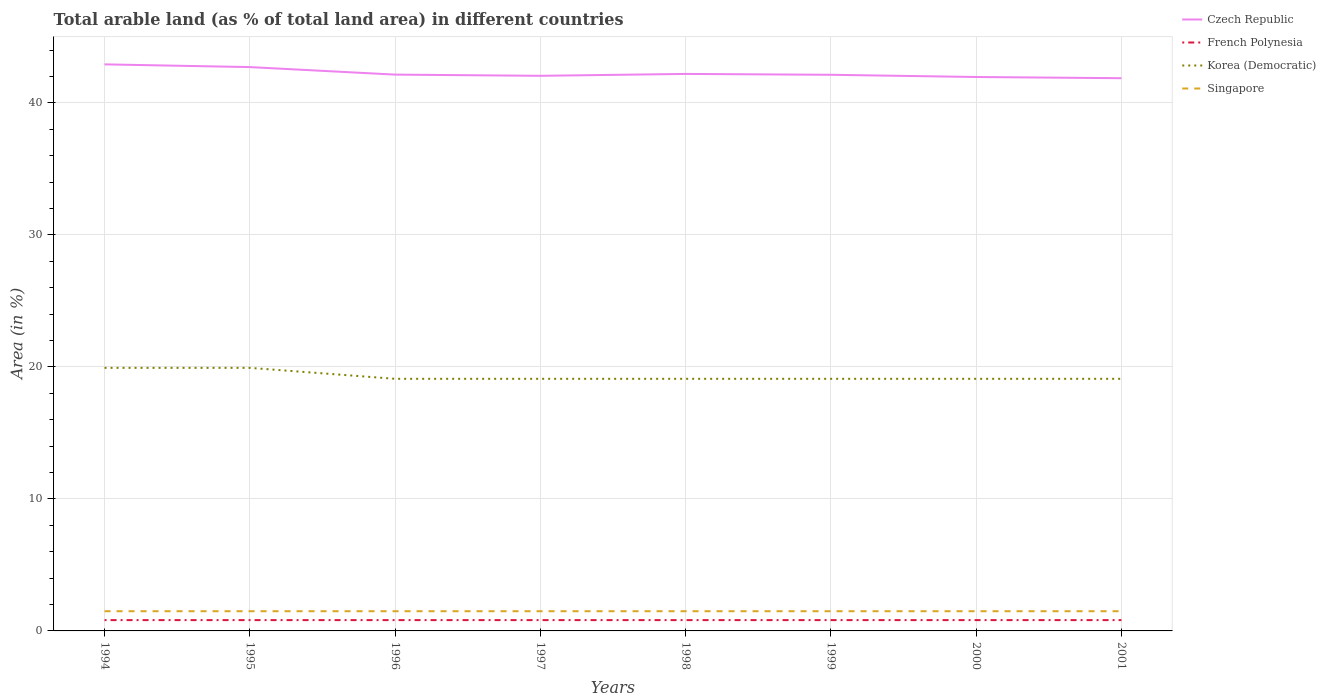How many different coloured lines are there?
Provide a succinct answer. 4. Is the number of lines equal to the number of legend labels?
Ensure brevity in your answer.  Yes. Across all years, what is the maximum percentage of arable land in Singapore?
Ensure brevity in your answer.  1.49. In which year was the percentage of arable land in French Polynesia maximum?
Your answer should be compact. 1994. What is the total percentage of arable land in Czech Republic in the graph?
Provide a short and direct response. 0.23. What is the difference between the highest and the second highest percentage of arable land in Czech Republic?
Keep it short and to the point. 1.05. Is the percentage of arable land in Czech Republic strictly greater than the percentage of arable land in Korea (Democratic) over the years?
Give a very brief answer. No. How many lines are there?
Make the answer very short. 4. How many years are there in the graph?
Your response must be concise. 8. What is the difference between two consecutive major ticks on the Y-axis?
Ensure brevity in your answer.  10. Are the values on the major ticks of Y-axis written in scientific E-notation?
Your answer should be very brief. No. Where does the legend appear in the graph?
Give a very brief answer. Top right. How many legend labels are there?
Offer a very short reply. 4. What is the title of the graph?
Offer a very short reply. Total arable land (as % of total land area) in different countries. Does "Zimbabwe" appear as one of the legend labels in the graph?
Your response must be concise. No. What is the label or title of the X-axis?
Keep it short and to the point. Years. What is the label or title of the Y-axis?
Your answer should be very brief. Area (in %). What is the Area (in %) of Czech Republic in 1994?
Offer a terse response. 42.93. What is the Area (in %) in French Polynesia in 1994?
Offer a terse response. 0.82. What is the Area (in %) of Korea (Democratic) in 1994?
Ensure brevity in your answer.  19.93. What is the Area (in %) in Singapore in 1994?
Keep it short and to the point. 1.49. What is the Area (in %) of Czech Republic in 1995?
Your answer should be very brief. 42.72. What is the Area (in %) of French Polynesia in 1995?
Give a very brief answer. 0.82. What is the Area (in %) of Korea (Democratic) in 1995?
Offer a terse response. 19.93. What is the Area (in %) in Singapore in 1995?
Your response must be concise. 1.49. What is the Area (in %) in Czech Republic in 1996?
Make the answer very short. 42.15. What is the Area (in %) of French Polynesia in 1996?
Offer a terse response. 0.82. What is the Area (in %) in Korea (Democratic) in 1996?
Offer a very short reply. 19.1. What is the Area (in %) in Singapore in 1996?
Keep it short and to the point. 1.49. What is the Area (in %) in Czech Republic in 1997?
Offer a terse response. 42.06. What is the Area (in %) in French Polynesia in 1997?
Provide a short and direct response. 0.82. What is the Area (in %) of Korea (Democratic) in 1997?
Your answer should be compact. 19.1. What is the Area (in %) in Singapore in 1997?
Provide a short and direct response. 1.49. What is the Area (in %) of Czech Republic in 1998?
Offer a very short reply. 42.2. What is the Area (in %) in French Polynesia in 1998?
Your answer should be very brief. 0.82. What is the Area (in %) in Korea (Democratic) in 1998?
Offer a terse response. 19.1. What is the Area (in %) in Singapore in 1998?
Ensure brevity in your answer.  1.49. What is the Area (in %) in Czech Republic in 1999?
Ensure brevity in your answer.  42.14. What is the Area (in %) in French Polynesia in 1999?
Your answer should be very brief. 0.82. What is the Area (in %) of Korea (Democratic) in 1999?
Ensure brevity in your answer.  19.1. What is the Area (in %) in Singapore in 1999?
Ensure brevity in your answer.  1.49. What is the Area (in %) of Czech Republic in 2000?
Offer a very short reply. 41.97. What is the Area (in %) in French Polynesia in 2000?
Your answer should be very brief. 0.82. What is the Area (in %) of Korea (Democratic) in 2000?
Your answer should be compact. 19.1. What is the Area (in %) of Singapore in 2000?
Offer a very short reply. 1.49. What is the Area (in %) in Czech Republic in 2001?
Offer a terse response. 41.88. What is the Area (in %) in French Polynesia in 2001?
Your answer should be very brief. 0.82. What is the Area (in %) in Korea (Democratic) in 2001?
Your answer should be compact. 19.1. What is the Area (in %) of Singapore in 2001?
Your answer should be very brief. 1.49. Across all years, what is the maximum Area (in %) in Czech Republic?
Give a very brief answer. 42.93. Across all years, what is the maximum Area (in %) in French Polynesia?
Make the answer very short. 0.82. Across all years, what is the maximum Area (in %) in Korea (Democratic)?
Make the answer very short. 19.93. Across all years, what is the maximum Area (in %) of Singapore?
Keep it short and to the point. 1.49. Across all years, what is the minimum Area (in %) in Czech Republic?
Make the answer very short. 41.88. Across all years, what is the minimum Area (in %) of French Polynesia?
Ensure brevity in your answer.  0.82. Across all years, what is the minimum Area (in %) of Korea (Democratic)?
Ensure brevity in your answer.  19.1. Across all years, what is the minimum Area (in %) in Singapore?
Your response must be concise. 1.49. What is the total Area (in %) of Czech Republic in the graph?
Provide a short and direct response. 338.05. What is the total Area (in %) of French Polynesia in the graph?
Give a very brief answer. 6.56. What is the total Area (in %) of Korea (Democratic) in the graph?
Your response must be concise. 154.47. What is the total Area (in %) in Singapore in the graph?
Your answer should be very brief. 11.94. What is the difference between the Area (in %) of Czech Republic in 1994 and that in 1995?
Offer a terse response. 0.21. What is the difference between the Area (in %) of French Polynesia in 1994 and that in 1995?
Ensure brevity in your answer.  0. What is the difference between the Area (in %) of Korea (Democratic) in 1994 and that in 1995?
Provide a short and direct response. 0. What is the difference between the Area (in %) of Czech Republic in 1994 and that in 1996?
Offer a terse response. 0.78. What is the difference between the Area (in %) of French Polynesia in 1994 and that in 1996?
Your answer should be very brief. 0. What is the difference between the Area (in %) in Korea (Democratic) in 1994 and that in 1996?
Give a very brief answer. 0.83. What is the difference between the Area (in %) of Czech Republic in 1994 and that in 1997?
Provide a short and direct response. 0.87. What is the difference between the Area (in %) of Korea (Democratic) in 1994 and that in 1997?
Offer a terse response. 0.83. What is the difference between the Area (in %) of Singapore in 1994 and that in 1997?
Give a very brief answer. 0. What is the difference between the Area (in %) of Czech Republic in 1994 and that in 1998?
Your answer should be compact. 0.72. What is the difference between the Area (in %) in Korea (Democratic) in 1994 and that in 1998?
Your answer should be very brief. 0.83. What is the difference between the Area (in %) in Singapore in 1994 and that in 1998?
Provide a succinct answer. 0. What is the difference between the Area (in %) in Czech Republic in 1994 and that in 1999?
Provide a short and direct response. 0.79. What is the difference between the Area (in %) of French Polynesia in 1994 and that in 1999?
Offer a very short reply. 0. What is the difference between the Area (in %) of Korea (Democratic) in 1994 and that in 1999?
Provide a short and direct response. 0.83. What is the difference between the Area (in %) in Czech Republic in 1994 and that in 2000?
Keep it short and to the point. 0.96. What is the difference between the Area (in %) in Korea (Democratic) in 1994 and that in 2000?
Keep it short and to the point. 0.83. What is the difference between the Area (in %) of Czech Republic in 1994 and that in 2001?
Keep it short and to the point. 1.05. What is the difference between the Area (in %) in French Polynesia in 1994 and that in 2001?
Offer a terse response. 0. What is the difference between the Area (in %) of Korea (Democratic) in 1994 and that in 2001?
Provide a succinct answer. 0.83. What is the difference between the Area (in %) of Czech Republic in 1995 and that in 1996?
Your response must be concise. 0.57. What is the difference between the Area (in %) in French Polynesia in 1995 and that in 1996?
Your answer should be very brief. 0. What is the difference between the Area (in %) in Korea (Democratic) in 1995 and that in 1996?
Ensure brevity in your answer.  0.83. What is the difference between the Area (in %) of Czech Republic in 1995 and that in 1997?
Give a very brief answer. 0.66. What is the difference between the Area (in %) of French Polynesia in 1995 and that in 1997?
Your response must be concise. 0. What is the difference between the Area (in %) of Korea (Democratic) in 1995 and that in 1997?
Your response must be concise. 0.83. What is the difference between the Area (in %) of Singapore in 1995 and that in 1997?
Give a very brief answer. 0. What is the difference between the Area (in %) of Czech Republic in 1995 and that in 1998?
Ensure brevity in your answer.  0.52. What is the difference between the Area (in %) in French Polynesia in 1995 and that in 1998?
Keep it short and to the point. 0. What is the difference between the Area (in %) of Korea (Democratic) in 1995 and that in 1998?
Make the answer very short. 0.83. What is the difference between the Area (in %) of Czech Republic in 1995 and that in 1999?
Give a very brief answer. 0.58. What is the difference between the Area (in %) in Korea (Democratic) in 1995 and that in 1999?
Provide a succinct answer. 0.83. What is the difference between the Area (in %) of Singapore in 1995 and that in 1999?
Your answer should be compact. 0. What is the difference between the Area (in %) in Czech Republic in 1995 and that in 2000?
Give a very brief answer. 0.75. What is the difference between the Area (in %) in Korea (Democratic) in 1995 and that in 2000?
Offer a very short reply. 0.83. What is the difference between the Area (in %) of Czech Republic in 1995 and that in 2001?
Keep it short and to the point. 0.84. What is the difference between the Area (in %) of French Polynesia in 1995 and that in 2001?
Provide a succinct answer. 0. What is the difference between the Area (in %) in Korea (Democratic) in 1995 and that in 2001?
Offer a terse response. 0.83. What is the difference between the Area (in %) in Czech Republic in 1996 and that in 1997?
Your answer should be very brief. 0.09. What is the difference between the Area (in %) in Korea (Democratic) in 1996 and that in 1997?
Make the answer very short. 0. What is the difference between the Area (in %) of Czech Republic in 1996 and that in 1998?
Offer a terse response. -0.05. What is the difference between the Area (in %) of Singapore in 1996 and that in 1998?
Your answer should be very brief. 0. What is the difference between the Area (in %) of Czech Republic in 1996 and that in 1999?
Your answer should be compact. 0.01. What is the difference between the Area (in %) of Czech Republic in 1996 and that in 2000?
Provide a succinct answer. 0.18. What is the difference between the Area (in %) in Czech Republic in 1996 and that in 2001?
Keep it short and to the point. 0.27. What is the difference between the Area (in %) of French Polynesia in 1996 and that in 2001?
Offer a very short reply. 0. What is the difference between the Area (in %) of Singapore in 1996 and that in 2001?
Provide a short and direct response. 0. What is the difference between the Area (in %) in Czech Republic in 1997 and that in 1998?
Ensure brevity in your answer.  -0.14. What is the difference between the Area (in %) in Singapore in 1997 and that in 1998?
Offer a terse response. 0. What is the difference between the Area (in %) of Czech Republic in 1997 and that in 1999?
Offer a very short reply. -0.08. What is the difference between the Area (in %) in French Polynesia in 1997 and that in 1999?
Ensure brevity in your answer.  0. What is the difference between the Area (in %) of Czech Republic in 1997 and that in 2000?
Offer a very short reply. 0.09. What is the difference between the Area (in %) in Czech Republic in 1997 and that in 2001?
Ensure brevity in your answer.  0.18. What is the difference between the Area (in %) of French Polynesia in 1997 and that in 2001?
Provide a short and direct response. 0. What is the difference between the Area (in %) of Korea (Democratic) in 1997 and that in 2001?
Your answer should be very brief. 0. What is the difference between the Area (in %) in Czech Republic in 1998 and that in 1999?
Your answer should be compact. 0.06. What is the difference between the Area (in %) in French Polynesia in 1998 and that in 1999?
Keep it short and to the point. 0. What is the difference between the Area (in %) in Czech Republic in 1998 and that in 2000?
Give a very brief answer. 0.23. What is the difference between the Area (in %) in Singapore in 1998 and that in 2000?
Provide a succinct answer. 0. What is the difference between the Area (in %) in Czech Republic in 1998 and that in 2001?
Make the answer very short. 0.32. What is the difference between the Area (in %) of Korea (Democratic) in 1998 and that in 2001?
Give a very brief answer. 0. What is the difference between the Area (in %) in Czech Republic in 1999 and that in 2000?
Your answer should be very brief. 0.17. What is the difference between the Area (in %) in Czech Republic in 1999 and that in 2001?
Your answer should be compact. 0.26. What is the difference between the Area (in %) in Korea (Democratic) in 1999 and that in 2001?
Your response must be concise. 0. What is the difference between the Area (in %) in Singapore in 1999 and that in 2001?
Offer a terse response. 0. What is the difference between the Area (in %) of Czech Republic in 2000 and that in 2001?
Offer a terse response. 0.09. What is the difference between the Area (in %) of Korea (Democratic) in 2000 and that in 2001?
Keep it short and to the point. 0. What is the difference between the Area (in %) in Singapore in 2000 and that in 2001?
Offer a terse response. 0. What is the difference between the Area (in %) of Czech Republic in 1994 and the Area (in %) of French Polynesia in 1995?
Offer a very short reply. 42.11. What is the difference between the Area (in %) in Czech Republic in 1994 and the Area (in %) in Korea (Democratic) in 1995?
Provide a succinct answer. 23. What is the difference between the Area (in %) in Czech Republic in 1994 and the Area (in %) in Singapore in 1995?
Provide a short and direct response. 41.43. What is the difference between the Area (in %) in French Polynesia in 1994 and the Area (in %) in Korea (Democratic) in 1995?
Your answer should be very brief. -19.11. What is the difference between the Area (in %) in French Polynesia in 1994 and the Area (in %) in Singapore in 1995?
Provide a short and direct response. -0.67. What is the difference between the Area (in %) in Korea (Democratic) in 1994 and the Area (in %) in Singapore in 1995?
Offer a very short reply. 18.44. What is the difference between the Area (in %) of Czech Republic in 1994 and the Area (in %) of French Polynesia in 1996?
Give a very brief answer. 42.11. What is the difference between the Area (in %) in Czech Republic in 1994 and the Area (in %) in Korea (Democratic) in 1996?
Provide a succinct answer. 23.83. What is the difference between the Area (in %) of Czech Republic in 1994 and the Area (in %) of Singapore in 1996?
Provide a succinct answer. 41.43. What is the difference between the Area (in %) in French Polynesia in 1994 and the Area (in %) in Korea (Democratic) in 1996?
Your answer should be compact. -18.28. What is the difference between the Area (in %) in French Polynesia in 1994 and the Area (in %) in Singapore in 1996?
Your answer should be compact. -0.67. What is the difference between the Area (in %) of Korea (Democratic) in 1994 and the Area (in %) of Singapore in 1996?
Offer a very short reply. 18.44. What is the difference between the Area (in %) of Czech Republic in 1994 and the Area (in %) of French Polynesia in 1997?
Make the answer very short. 42.11. What is the difference between the Area (in %) in Czech Republic in 1994 and the Area (in %) in Korea (Democratic) in 1997?
Your answer should be very brief. 23.83. What is the difference between the Area (in %) of Czech Republic in 1994 and the Area (in %) of Singapore in 1997?
Your response must be concise. 41.43. What is the difference between the Area (in %) in French Polynesia in 1994 and the Area (in %) in Korea (Democratic) in 1997?
Provide a succinct answer. -18.28. What is the difference between the Area (in %) in French Polynesia in 1994 and the Area (in %) in Singapore in 1997?
Ensure brevity in your answer.  -0.67. What is the difference between the Area (in %) of Korea (Democratic) in 1994 and the Area (in %) of Singapore in 1997?
Keep it short and to the point. 18.44. What is the difference between the Area (in %) in Czech Republic in 1994 and the Area (in %) in French Polynesia in 1998?
Provide a short and direct response. 42.11. What is the difference between the Area (in %) of Czech Republic in 1994 and the Area (in %) of Korea (Democratic) in 1998?
Provide a short and direct response. 23.83. What is the difference between the Area (in %) in Czech Republic in 1994 and the Area (in %) in Singapore in 1998?
Keep it short and to the point. 41.43. What is the difference between the Area (in %) of French Polynesia in 1994 and the Area (in %) of Korea (Democratic) in 1998?
Ensure brevity in your answer.  -18.28. What is the difference between the Area (in %) of French Polynesia in 1994 and the Area (in %) of Singapore in 1998?
Keep it short and to the point. -0.67. What is the difference between the Area (in %) in Korea (Democratic) in 1994 and the Area (in %) in Singapore in 1998?
Offer a terse response. 18.44. What is the difference between the Area (in %) of Czech Republic in 1994 and the Area (in %) of French Polynesia in 1999?
Your answer should be very brief. 42.11. What is the difference between the Area (in %) in Czech Republic in 1994 and the Area (in %) in Korea (Democratic) in 1999?
Your response must be concise. 23.83. What is the difference between the Area (in %) of Czech Republic in 1994 and the Area (in %) of Singapore in 1999?
Give a very brief answer. 41.43. What is the difference between the Area (in %) in French Polynesia in 1994 and the Area (in %) in Korea (Democratic) in 1999?
Offer a terse response. -18.28. What is the difference between the Area (in %) in French Polynesia in 1994 and the Area (in %) in Singapore in 1999?
Make the answer very short. -0.67. What is the difference between the Area (in %) of Korea (Democratic) in 1994 and the Area (in %) of Singapore in 1999?
Offer a terse response. 18.44. What is the difference between the Area (in %) of Czech Republic in 1994 and the Area (in %) of French Polynesia in 2000?
Keep it short and to the point. 42.11. What is the difference between the Area (in %) in Czech Republic in 1994 and the Area (in %) in Korea (Democratic) in 2000?
Your answer should be compact. 23.83. What is the difference between the Area (in %) of Czech Republic in 1994 and the Area (in %) of Singapore in 2000?
Your answer should be compact. 41.43. What is the difference between the Area (in %) of French Polynesia in 1994 and the Area (in %) of Korea (Democratic) in 2000?
Offer a very short reply. -18.28. What is the difference between the Area (in %) of French Polynesia in 1994 and the Area (in %) of Singapore in 2000?
Offer a very short reply. -0.67. What is the difference between the Area (in %) of Korea (Democratic) in 1994 and the Area (in %) of Singapore in 2000?
Make the answer very short. 18.44. What is the difference between the Area (in %) of Czech Republic in 1994 and the Area (in %) of French Polynesia in 2001?
Your answer should be compact. 42.11. What is the difference between the Area (in %) in Czech Republic in 1994 and the Area (in %) in Korea (Democratic) in 2001?
Keep it short and to the point. 23.83. What is the difference between the Area (in %) of Czech Republic in 1994 and the Area (in %) of Singapore in 2001?
Give a very brief answer. 41.43. What is the difference between the Area (in %) of French Polynesia in 1994 and the Area (in %) of Korea (Democratic) in 2001?
Make the answer very short. -18.28. What is the difference between the Area (in %) in French Polynesia in 1994 and the Area (in %) in Singapore in 2001?
Make the answer very short. -0.67. What is the difference between the Area (in %) of Korea (Democratic) in 1994 and the Area (in %) of Singapore in 2001?
Provide a short and direct response. 18.44. What is the difference between the Area (in %) in Czech Republic in 1995 and the Area (in %) in French Polynesia in 1996?
Make the answer very short. 41.9. What is the difference between the Area (in %) in Czech Republic in 1995 and the Area (in %) in Korea (Democratic) in 1996?
Your response must be concise. 23.62. What is the difference between the Area (in %) in Czech Republic in 1995 and the Area (in %) in Singapore in 1996?
Provide a succinct answer. 41.23. What is the difference between the Area (in %) in French Polynesia in 1995 and the Area (in %) in Korea (Democratic) in 1996?
Your response must be concise. -18.28. What is the difference between the Area (in %) in French Polynesia in 1995 and the Area (in %) in Singapore in 1996?
Provide a succinct answer. -0.67. What is the difference between the Area (in %) in Korea (Democratic) in 1995 and the Area (in %) in Singapore in 1996?
Keep it short and to the point. 18.44. What is the difference between the Area (in %) of Czech Republic in 1995 and the Area (in %) of French Polynesia in 1997?
Ensure brevity in your answer.  41.9. What is the difference between the Area (in %) in Czech Republic in 1995 and the Area (in %) in Korea (Democratic) in 1997?
Make the answer very short. 23.62. What is the difference between the Area (in %) in Czech Republic in 1995 and the Area (in %) in Singapore in 1997?
Offer a very short reply. 41.23. What is the difference between the Area (in %) in French Polynesia in 1995 and the Area (in %) in Korea (Democratic) in 1997?
Offer a very short reply. -18.28. What is the difference between the Area (in %) in French Polynesia in 1995 and the Area (in %) in Singapore in 1997?
Provide a succinct answer. -0.67. What is the difference between the Area (in %) of Korea (Democratic) in 1995 and the Area (in %) of Singapore in 1997?
Keep it short and to the point. 18.44. What is the difference between the Area (in %) of Czech Republic in 1995 and the Area (in %) of French Polynesia in 1998?
Your response must be concise. 41.9. What is the difference between the Area (in %) in Czech Republic in 1995 and the Area (in %) in Korea (Democratic) in 1998?
Your response must be concise. 23.62. What is the difference between the Area (in %) of Czech Republic in 1995 and the Area (in %) of Singapore in 1998?
Provide a short and direct response. 41.23. What is the difference between the Area (in %) of French Polynesia in 1995 and the Area (in %) of Korea (Democratic) in 1998?
Offer a very short reply. -18.28. What is the difference between the Area (in %) in French Polynesia in 1995 and the Area (in %) in Singapore in 1998?
Give a very brief answer. -0.67. What is the difference between the Area (in %) in Korea (Democratic) in 1995 and the Area (in %) in Singapore in 1998?
Offer a very short reply. 18.44. What is the difference between the Area (in %) in Czech Republic in 1995 and the Area (in %) in French Polynesia in 1999?
Provide a succinct answer. 41.9. What is the difference between the Area (in %) in Czech Republic in 1995 and the Area (in %) in Korea (Democratic) in 1999?
Offer a terse response. 23.62. What is the difference between the Area (in %) in Czech Republic in 1995 and the Area (in %) in Singapore in 1999?
Offer a terse response. 41.23. What is the difference between the Area (in %) in French Polynesia in 1995 and the Area (in %) in Korea (Democratic) in 1999?
Your response must be concise. -18.28. What is the difference between the Area (in %) of French Polynesia in 1995 and the Area (in %) of Singapore in 1999?
Keep it short and to the point. -0.67. What is the difference between the Area (in %) of Korea (Democratic) in 1995 and the Area (in %) of Singapore in 1999?
Keep it short and to the point. 18.44. What is the difference between the Area (in %) in Czech Republic in 1995 and the Area (in %) in French Polynesia in 2000?
Your answer should be very brief. 41.9. What is the difference between the Area (in %) of Czech Republic in 1995 and the Area (in %) of Korea (Democratic) in 2000?
Keep it short and to the point. 23.62. What is the difference between the Area (in %) in Czech Republic in 1995 and the Area (in %) in Singapore in 2000?
Keep it short and to the point. 41.23. What is the difference between the Area (in %) in French Polynesia in 1995 and the Area (in %) in Korea (Democratic) in 2000?
Your answer should be compact. -18.28. What is the difference between the Area (in %) of French Polynesia in 1995 and the Area (in %) of Singapore in 2000?
Your answer should be compact. -0.67. What is the difference between the Area (in %) in Korea (Democratic) in 1995 and the Area (in %) in Singapore in 2000?
Provide a short and direct response. 18.44. What is the difference between the Area (in %) of Czech Republic in 1995 and the Area (in %) of French Polynesia in 2001?
Keep it short and to the point. 41.9. What is the difference between the Area (in %) of Czech Republic in 1995 and the Area (in %) of Korea (Democratic) in 2001?
Your answer should be very brief. 23.62. What is the difference between the Area (in %) in Czech Republic in 1995 and the Area (in %) in Singapore in 2001?
Ensure brevity in your answer.  41.23. What is the difference between the Area (in %) of French Polynesia in 1995 and the Area (in %) of Korea (Democratic) in 2001?
Offer a terse response. -18.28. What is the difference between the Area (in %) in French Polynesia in 1995 and the Area (in %) in Singapore in 2001?
Provide a short and direct response. -0.67. What is the difference between the Area (in %) of Korea (Democratic) in 1995 and the Area (in %) of Singapore in 2001?
Your response must be concise. 18.44. What is the difference between the Area (in %) in Czech Republic in 1996 and the Area (in %) in French Polynesia in 1997?
Make the answer very short. 41.33. What is the difference between the Area (in %) in Czech Republic in 1996 and the Area (in %) in Korea (Democratic) in 1997?
Provide a succinct answer. 23.05. What is the difference between the Area (in %) of Czech Republic in 1996 and the Area (in %) of Singapore in 1997?
Provide a short and direct response. 40.66. What is the difference between the Area (in %) of French Polynesia in 1996 and the Area (in %) of Korea (Democratic) in 1997?
Ensure brevity in your answer.  -18.28. What is the difference between the Area (in %) of French Polynesia in 1996 and the Area (in %) of Singapore in 1997?
Your answer should be very brief. -0.67. What is the difference between the Area (in %) of Korea (Democratic) in 1996 and the Area (in %) of Singapore in 1997?
Make the answer very short. 17.61. What is the difference between the Area (in %) in Czech Republic in 1996 and the Area (in %) in French Polynesia in 1998?
Your answer should be very brief. 41.33. What is the difference between the Area (in %) of Czech Republic in 1996 and the Area (in %) of Korea (Democratic) in 1998?
Give a very brief answer. 23.05. What is the difference between the Area (in %) of Czech Republic in 1996 and the Area (in %) of Singapore in 1998?
Your answer should be compact. 40.66. What is the difference between the Area (in %) of French Polynesia in 1996 and the Area (in %) of Korea (Democratic) in 1998?
Provide a succinct answer. -18.28. What is the difference between the Area (in %) in French Polynesia in 1996 and the Area (in %) in Singapore in 1998?
Offer a very short reply. -0.67. What is the difference between the Area (in %) in Korea (Democratic) in 1996 and the Area (in %) in Singapore in 1998?
Give a very brief answer. 17.61. What is the difference between the Area (in %) of Czech Republic in 1996 and the Area (in %) of French Polynesia in 1999?
Provide a succinct answer. 41.33. What is the difference between the Area (in %) of Czech Republic in 1996 and the Area (in %) of Korea (Democratic) in 1999?
Make the answer very short. 23.05. What is the difference between the Area (in %) of Czech Republic in 1996 and the Area (in %) of Singapore in 1999?
Offer a terse response. 40.66. What is the difference between the Area (in %) of French Polynesia in 1996 and the Area (in %) of Korea (Democratic) in 1999?
Your answer should be compact. -18.28. What is the difference between the Area (in %) of French Polynesia in 1996 and the Area (in %) of Singapore in 1999?
Keep it short and to the point. -0.67. What is the difference between the Area (in %) of Korea (Democratic) in 1996 and the Area (in %) of Singapore in 1999?
Provide a succinct answer. 17.61. What is the difference between the Area (in %) in Czech Republic in 1996 and the Area (in %) in French Polynesia in 2000?
Make the answer very short. 41.33. What is the difference between the Area (in %) in Czech Republic in 1996 and the Area (in %) in Korea (Democratic) in 2000?
Offer a very short reply. 23.05. What is the difference between the Area (in %) of Czech Republic in 1996 and the Area (in %) of Singapore in 2000?
Ensure brevity in your answer.  40.66. What is the difference between the Area (in %) in French Polynesia in 1996 and the Area (in %) in Korea (Democratic) in 2000?
Ensure brevity in your answer.  -18.28. What is the difference between the Area (in %) in French Polynesia in 1996 and the Area (in %) in Singapore in 2000?
Your response must be concise. -0.67. What is the difference between the Area (in %) in Korea (Democratic) in 1996 and the Area (in %) in Singapore in 2000?
Keep it short and to the point. 17.61. What is the difference between the Area (in %) of Czech Republic in 1996 and the Area (in %) of French Polynesia in 2001?
Your response must be concise. 41.33. What is the difference between the Area (in %) of Czech Republic in 1996 and the Area (in %) of Korea (Democratic) in 2001?
Offer a terse response. 23.05. What is the difference between the Area (in %) in Czech Republic in 1996 and the Area (in %) in Singapore in 2001?
Offer a terse response. 40.66. What is the difference between the Area (in %) of French Polynesia in 1996 and the Area (in %) of Korea (Democratic) in 2001?
Your response must be concise. -18.28. What is the difference between the Area (in %) of French Polynesia in 1996 and the Area (in %) of Singapore in 2001?
Provide a short and direct response. -0.67. What is the difference between the Area (in %) of Korea (Democratic) in 1996 and the Area (in %) of Singapore in 2001?
Keep it short and to the point. 17.61. What is the difference between the Area (in %) in Czech Republic in 1997 and the Area (in %) in French Polynesia in 1998?
Your response must be concise. 41.24. What is the difference between the Area (in %) in Czech Republic in 1997 and the Area (in %) in Korea (Democratic) in 1998?
Offer a terse response. 22.96. What is the difference between the Area (in %) of Czech Republic in 1997 and the Area (in %) of Singapore in 1998?
Provide a succinct answer. 40.57. What is the difference between the Area (in %) of French Polynesia in 1997 and the Area (in %) of Korea (Democratic) in 1998?
Offer a very short reply. -18.28. What is the difference between the Area (in %) of French Polynesia in 1997 and the Area (in %) of Singapore in 1998?
Your answer should be very brief. -0.67. What is the difference between the Area (in %) in Korea (Democratic) in 1997 and the Area (in %) in Singapore in 1998?
Offer a terse response. 17.61. What is the difference between the Area (in %) of Czech Republic in 1997 and the Area (in %) of French Polynesia in 1999?
Provide a succinct answer. 41.24. What is the difference between the Area (in %) of Czech Republic in 1997 and the Area (in %) of Korea (Democratic) in 1999?
Provide a short and direct response. 22.96. What is the difference between the Area (in %) in Czech Republic in 1997 and the Area (in %) in Singapore in 1999?
Give a very brief answer. 40.57. What is the difference between the Area (in %) in French Polynesia in 1997 and the Area (in %) in Korea (Democratic) in 1999?
Ensure brevity in your answer.  -18.28. What is the difference between the Area (in %) of French Polynesia in 1997 and the Area (in %) of Singapore in 1999?
Provide a short and direct response. -0.67. What is the difference between the Area (in %) in Korea (Democratic) in 1997 and the Area (in %) in Singapore in 1999?
Your response must be concise. 17.61. What is the difference between the Area (in %) in Czech Republic in 1997 and the Area (in %) in French Polynesia in 2000?
Keep it short and to the point. 41.24. What is the difference between the Area (in %) of Czech Republic in 1997 and the Area (in %) of Korea (Democratic) in 2000?
Offer a terse response. 22.96. What is the difference between the Area (in %) in Czech Republic in 1997 and the Area (in %) in Singapore in 2000?
Offer a very short reply. 40.57. What is the difference between the Area (in %) of French Polynesia in 1997 and the Area (in %) of Korea (Democratic) in 2000?
Provide a short and direct response. -18.28. What is the difference between the Area (in %) of French Polynesia in 1997 and the Area (in %) of Singapore in 2000?
Provide a short and direct response. -0.67. What is the difference between the Area (in %) of Korea (Democratic) in 1997 and the Area (in %) of Singapore in 2000?
Your response must be concise. 17.61. What is the difference between the Area (in %) in Czech Republic in 1997 and the Area (in %) in French Polynesia in 2001?
Provide a short and direct response. 41.24. What is the difference between the Area (in %) of Czech Republic in 1997 and the Area (in %) of Korea (Democratic) in 2001?
Your answer should be very brief. 22.96. What is the difference between the Area (in %) in Czech Republic in 1997 and the Area (in %) in Singapore in 2001?
Make the answer very short. 40.57. What is the difference between the Area (in %) in French Polynesia in 1997 and the Area (in %) in Korea (Democratic) in 2001?
Keep it short and to the point. -18.28. What is the difference between the Area (in %) of French Polynesia in 1997 and the Area (in %) of Singapore in 2001?
Offer a very short reply. -0.67. What is the difference between the Area (in %) in Korea (Democratic) in 1997 and the Area (in %) in Singapore in 2001?
Provide a succinct answer. 17.61. What is the difference between the Area (in %) of Czech Republic in 1998 and the Area (in %) of French Polynesia in 1999?
Keep it short and to the point. 41.38. What is the difference between the Area (in %) in Czech Republic in 1998 and the Area (in %) in Korea (Democratic) in 1999?
Provide a succinct answer. 23.1. What is the difference between the Area (in %) in Czech Republic in 1998 and the Area (in %) in Singapore in 1999?
Offer a terse response. 40.71. What is the difference between the Area (in %) in French Polynesia in 1998 and the Area (in %) in Korea (Democratic) in 1999?
Make the answer very short. -18.28. What is the difference between the Area (in %) of French Polynesia in 1998 and the Area (in %) of Singapore in 1999?
Your response must be concise. -0.67. What is the difference between the Area (in %) of Korea (Democratic) in 1998 and the Area (in %) of Singapore in 1999?
Your answer should be very brief. 17.61. What is the difference between the Area (in %) of Czech Republic in 1998 and the Area (in %) of French Polynesia in 2000?
Keep it short and to the point. 41.38. What is the difference between the Area (in %) in Czech Republic in 1998 and the Area (in %) in Korea (Democratic) in 2000?
Make the answer very short. 23.1. What is the difference between the Area (in %) in Czech Republic in 1998 and the Area (in %) in Singapore in 2000?
Provide a succinct answer. 40.71. What is the difference between the Area (in %) in French Polynesia in 1998 and the Area (in %) in Korea (Democratic) in 2000?
Give a very brief answer. -18.28. What is the difference between the Area (in %) of French Polynesia in 1998 and the Area (in %) of Singapore in 2000?
Your answer should be compact. -0.67. What is the difference between the Area (in %) of Korea (Democratic) in 1998 and the Area (in %) of Singapore in 2000?
Offer a very short reply. 17.61. What is the difference between the Area (in %) of Czech Republic in 1998 and the Area (in %) of French Polynesia in 2001?
Your answer should be compact. 41.38. What is the difference between the Area (in %) of Czech Republic in 1998 and the Area (in %) of Korea (Democratic) in 2001?
Offer a terse response. 23.1. What is the difference between the Area (in %) in Czech Republic in 1998 and the Area (in %) in Singapore in 2001?
Make the answer very short. 40.71. What is the difference between the Area (in %) in French Polynesia in 1998 and the Area (in %) in Korea (Democratic) in 2001?
Offer a very short reply. -18.28. What is the difference between the Area (in %) of French Polynesia in 1998 and the Area (in %) of Singapore in 2001?
Give a very brief answer. -0.67. What is the difference between the Area (in %) of Korea (Democratic) in 1998 and the Area (in %) of Singapore in 2001?
Provide a short and direct response. 17.61. What is the difference between the Area (in %) of Czech Republic in 1999 and the Area (in %) of French Polynesia in 2000?
Provide a succinct answer. 41.32. What is the difference between the Area (in %) in Czech Republic in 1999 and the Area (in %) in Korea (Democratic) in 2000?
Your answer should be compact. 23.04. What is the difference between the Area (in %) in Czech Republic in 1999 and the Area (in %) in Singapore in 2000?
Ensure brevity in your answer.  40.65. What is the difference between the Area (in %) in French Polynesia in 1999 and the Area (in %) in Korea (Democratic) in 2000?
Make the answer very short. -18.28. What is the difference between the Area (in %) in French Polynesia in 1999 and the Area (in %) in Singapore in 2000?
Give a very brief answer. -0.67. What is the difference between the Area (in %) in Korea (Democratic) in 1999 and the Area (in %) in Singapore in 2000?
Your answer should be very brief. 17.61. What is the difference between the Area (in %) in Czech Republic in 1999 and the Area (in %) in French Polynesia in 2001?
Your answer should be very brief. 41.32. What is the difference between the Area (in %) in Czech Republic in 1999 and the Area (in %) in Korea (Democratic) in 2001?
Ensure brevity in your answer.  23.04. What is the difference between the Area (in %) of Czech Republic in 1999 and the Area (in %) of Singapore in 2001?
Offer a very short reply. 40.65. What is the difference between the Area (in %) in French Polynesia in 1999 and the Area (in %) in Korea (Democratic) in 2001?
Give a very brief answer. -18.28. What is the difference between the Area (in %) of French Polynesia in 1999 and the Area (in %) of Singapore in 2001?
Make the answer very short. -0.67. What is the difference between the Area (in %) in Korea (Democratic) in 1999 and the Area (in %) in Singapore in 2001?
Make the answer very short. 17.61. What is the difference between the Area (in %) of Czech Republic in 2000 and the Area (in %) of French Polynesia in 2001?
Offer a terse response. 41.15. What is the difference between the Area (in %) in Czech Republic in 2000 and the Area (in %) in Korea (Democratic) in 2001?
Give a very brief answer. 22.87. What is the difference between the Area (in %) in Czech Republic in 2000 and the Area (in %) in Singapore in 2001?
Make the answer very short. 40.48. What is the difference between the Area (in %) in French Polynesia in 2000 and the Area (in %) in Korea (Democratic) in 2001?
Keep it short and to the point. -18.28. What is the difference between the Area (in %) in French Polynesia in 2000 and the Area (in %) in Singapore in 2001?
Ensure brevity in your answer.  -0.67. What is the difference between the Area (in %) of Korea (Democratic) in 2000 and the Area (in %) of Singapore in 2001?
Offer a very short reply. 17.61. What is the average Area (in %) in Czech Republic per year?
Your response must be concise. 42.26. What is the average Area (in %) of French Polynesia per year?
Offer a terse response. 0.82. What is the average Area (in %) of Korea (Democratic) per year?
Offer a very short reply. 19.31. What is the average Area (in %) in Singapore per year?
Make the answer very short. 1.49. In the year 1994, what is the difference between the Area (in %) of Czech Republic and Area (in %) of French Polynesia?
Your answer should be very brief. 42.11. In the year 1994, what is the difference between the Area (in %) in Czech Republic and Area (in %) in Korea (Democratic)?
Ensure brevity in your answer.  23. In the year 1994, what is the difference between the Area (in %) in Czech Republic and Area (in %) in Singapore?
Your response must be concise. 41.43. In the year 1994, what is the difference between the Area (in %) in French Polynesia and Area (in %) in Korea (Democratic)?
Keep it short and to the point. -19.11. In the year 1994, what is the difference between the Area (in %) of French Polynesia and Area (in %) of Singapore?
Keep it short and to the point. -0.67. In the year 1994, what is the difference between the Area (in %) of Korea (Democratic) and Area (in %) of Singapore?
Make the answer very short. 18.44. In the year 1995, what is the difference between the Area (in %) of Czech Republic and Area (in %) of French Polynesia?
Provide a short and direct response. 41.9. In the year 1995, what is the difference between the Area (in %) of Czech Republic and Area (in %) of Korea (Democratic)?
Ensure brevity in your answer.  22.79. In the year 1995, what is the difference between the Area (in %) of Czech Republic and Area (in %) of Singapore?
Your answer should be very brief. 41.23. In the year 1995, what is the difference between the Area (in %) of French Polynesia and Area (in %) of Korea (Democratic)?
Make the answer very short. -19.11. In the year 1995, what is the difference between the Area (in %) of French Polynesia and Area (in %) of Singapore?
Your response must be concise. -0.67. In the year 1995, what is the difference between the Area (in %) of Korea (Democratic) and Area (in %) of Singapore?
Make the answer very short. 18.44. In the year 1996, what is the difference between the Area (in %) in Czech Republic and Area (in %) in French Polynesia?
Your answer should be compact. 41.33. In the year 1996, what is the difference between the Area (in %) of Czech Republic and Area (in %) of Korea (Democratic)?
Provide a succinct answer. 23.05. In the year 1996, what is the difference between the Area (in %) of Czech Republic and Area (in %) of Singapore?
Keep it short and to the point. 40.66. In the year 1996, what is the difference between the Area (in %) of French Polynesia and Area (in %) of Korea (Democratic)?
Provide a succinct answer. -18.28. In the year 1996, what is the difference between the Area (in %) in French Polynesia and Area (in %) in Singapore?
Offer a very short reply. -0.67. In the year 1996, what is the difference between the Area (in %) of Korea (Democratic) and Area (in %) of Singapore?
Your answer should be compact. 17.61. In the year 1997, what is the difference between the Area (in %) in Czech Republic and Area (in %) in French Polynesia?
Your answer should be compact. 41.24. In the year 1997, what is the difference between the Area (in %) in Czech Republic and Area (in %) in Korea (Democratic)?
Keep it short and to the point. 22.96. In the year 1997, what is the difference between the Area (in %) of Czech Republic and Area (in %) of Singapore?
Your answer should be very brief. 40.57. In the year 1997, what is the difference between the Area (in %) of French Polynesia and Area (in %) of Korea (Democratic)?
Keep it short and to the point. -18.28. In the year 1997, what is the difference between the Area (in %) in French Polynesia and Area (in %) in Singapore?
Your answer should be very brief. -0.67. In the year 1997, what is the difference between the Area (in %) in Korea (Democratic) and Area (in %) in Singapore?
Your response must be concise. 17.61. In the year 1998, what is the difference between the Area (in %) of Czech Republic and Area (in %) of French Polynesia?
Provide a succinct answer. 41.38. In the year 1998, what is the difference between the Area (in %) in Czech Republic and Area (in %) in Korea (Democratic)?
Ensure brevity in your answer.  23.1. In the year 1998, what is the difference between the Area (in %) of Czech Republic and Area (in %) of Singapore?
Make the answer very short. 40.71. In the year 1998, what is the difference between the Area (in %) in French Polynesia and Area (in %) in Korea (Democratic)?
Provide a succinct answer. -18.28. In the year 1998, what is the difference between the Area (in %) in French Polynesia and Area (in %) in Singapore?
Provide a succinct answer. -0.67. In the year 1998, what is the difference between the Area (in %) in Korea (Democratic) and Area (in %) in Singapore?
Your answer should be very brief. 17.61. In the year 1999, what is the difference between the Area (in %) in Czech Republic and Area (in %) in French Polynesia?
Your answer should be compact. 41.32. In the year 1999, what is the difference between the Area (in %) in Czech Republic and Area (in %) in Korea (Democratic)?
Ensure brevity in your answer.  23.04. In the year 1999, what is the difference between the Area (in %) in Czech Republic and Area (in %) in Singapore?
Keep it short and to the point. 40.65. In the year 1999, what is the difference between the Area (in %) in French Polynesia and Area (in %) in Korea (Democratic)?
Offer a terse response. -18.28. In the year 1999, what is the difference between the Area (in %) of French Polynesia and Area (in %) of Singapore?
Provide a succinct answer. -0.67. In the year 1999, what is the difference between the Area (in %) in Korea (Democratic) and Area (in %) in Singapore?
Give a very brief answer. 17.61. In the year 2000, what is the difference between the Area (in %) in Czech Republic and Area (in %) in French Polynesia?
Your answer should be compact. 41.15. In the year 2000, what is the difference between the Area (in %) in Czech Republic and Area (in %) in Korea (Democratic)?
Your response must be concise. 22.87. In the year 2000, what is the difference between the Area (in %) of Czech Republic and Area (in %) of Singapore?
Ensure brevity in your answer.  40.48. In the year 2000, what is the difference between the Area (in %) of French Polynesia and Area (in %) of Korea (Democratic)?
Your response must be concise. -18.28. In the year 2000, what is the difference between the Area (in %) in French Polynesia and Area (in %) in Singapore?
Your answer should be compact. -0.67. In the year 2000, what is the difference between the Area (in %) in Korea (Democratic) and Area (in %) in Singapore?
Offer a terse response. 17.61. In the year 2001, what is the difference between the Area (in %) in Czech Republic and Area (in %) in French Polynesia?
Provide a short and direct response. 41.06. In the year 2001, what is the difference between the Area (in %) in Czech Republic and Area (in %) in Korea (Democratic)?
Ensure brevity in your answer.  22.78. In the year 2001, what is the difference between the Area (in %) of Czech Republic and Area (in %) of Singapore?
Your answer should be very brief. 40.39. In the year 2001, what is the difference between the Area (in %) in French Polynesia and Area (in %) in Korea (Democratic)?
Ensure brevity in your answer.  -18.28. In the year 2001, what is the difference between the Area (in %) in French Polynesia and Area (in %) in Singapore?
Offer a very short reply. -0.67. In the year 2001, what is the difference between the Area (in %) in Korea (Democratic) and Area (in %) in Singapore?
Offer a very short reply. 17.61. What is the ratio of the Area (in %) in Korea (Democratic) in 1994 to that in 1995?
Offer a terse response. 1. What is the ratio of the Area (in %) in Singapore in 1994 to that in 1995?
Give a very brief answer. 1. What is the ratio of the Area (in %) of Czech Republic in 1994 to that in 1996?
Provide a short and direct response. 1.02. What is the ratio of the Area (in %) in French Polynesia in 1994 to that in 1996?
Ensure brevity in your answer.  1. What is the ratio of the Area (in %) of Korea (Democratic) in 1994 to that in 1996?
Offer a terse response. 1.04. What is the ratio of the Area (in %) of Czech Republic in 1994 to that in 1997?
Provide a short and direct response. 1.02. What is the ratio of the Area (in %) in French Polynesia in 1994 to that in 1997?
Keep it short and to the point. 1. What is the ratio of the Area (in %) of Korea (Democratic) in 1994 to that in 1997?
Your answer should be very brief. 1.04. What is the ratio of the Area (in %) of Singapore in 1994 to that in 1997?
Provide a succinct answer. 1. What is the ratio of the Area (in %) in Czech Republic in 1994 to that in 1998?
Your response must be concise. 1.02. What is the ratio of the Area (in %) in Korea (Democratic) in 1994 to that in 1998?
Give a very brief answer. 1.04. What is the ratio of the Area (in %) in Czech Republic in 1994 to that in 1999?
Provide a short and direct response. 1.02. What is the ratio of the Area (in %) of French Polynesia in 1994 to that in 1999?
Provide a short and direct response. 1. What is the ratio of the Area (in %) of Korea (Democratic) in 1994 to that in 1999?
Ensure brevity in your answer.  1.04. What is the ratio of the Area (in %) of Singapore in 1994 to that in 1999?
Your answer should be very brief. 1. What is the ratio of the Area (in %) in Czech Republic in 1994 to that in 2000?
Make the answer very short. 1.02. What is the ratio of the Area (in %) of Korea (Democratic) in 1994 to that in 2000?
Ensure brevity in your answer.  1.04. What is the ratio of the Area (in %) of Singapore in 1994 to that in 2000?
Your answer should be compact. 1. What is the ratio of the Area (in %) in French Polynesia in 1994 to that in 2001?
Offer a terse response. 1. What is the ratio of the Area (in %) of Korea (Democratic) in 1994 to that in 2001?
Provide a succinct answer. 1.04. What is the ratio of the Area (in %) of Czech Republic in 1995 to that in 1996?
Offer a very short reply. 1.01. What is the ratio of the Area (in %) of Korea (Democratic) in 1995 to that in 1996?
Keep it short and to the point. 1.04. What is the ratio of the Area (in %) in Czech Republic in 1995 to that in 1997?
Give a very brief answer. 1.02. What is the ratio of the Area (in %) of Korea (Democratic) in 1995 to that in 1997?
Offer a terse response. 1.04. What is the ratio of the Area (in %) of Czech Republic in 1995 to that in 1998?
Provide a short and direct response. 1.01. What is the ratio of the Area (in %) of Korea (Democratic) in 1995 to that in 1998?
Provide a succinct answer. 1.04. What is the ratio of the Area (in %) of Czech Republic in 1995 to that in 1999?
Your answer should be very brief. 1.01. What is the ratio of the Area (in %) of French Polynesia in 1995 to that in 1999?
Give a very brief answer. 1. What is the ratio of the Area (in %) of Korea (Democratic) in 1995 to that in 1999?
Offer a very short reply. 1.04. What is the ratio of the Area (in %) of Czech Republic in 1995 to that in 2000?
Give a very brief answer. 1.02. What is the ratio of the Area (in %) in Korea (Democratic) in 1995 to that in 2000?
Ensure brevity in your answer.  1.04. What is the ratio of the Area (in %) of Singapore in 1995 to that in 2000?
Ensure brevity in your answer.  1. What is the ratio of the Area (in %) of Czech Republic in 1995 to that in 2001?
Your answer should be compact. 1.02. What is the ratio of the Area (in %) of Korea (Democratic) in 1995 to that in 2001?
Give a very brief answer. 1.04. What is the ratio of the Area (in %) in Singapore in 1995 to that in 2001?
Provide a succinct answer. 1. What is the ratio of the Area (in %) of Czech Republic in 1996 to that in 1997?
Make the answer very short. 1. What is the ratio of the Area (in %) of Korea (Democratic) in 1996 to that in 1997?
Your response must be concise. 1. What is the ratio of the Area (in %) in French Polynesia in 1996 to that in 1998?
Make the answer very short. 1. What is the ratio of the Area (in %) in Korea (Democratic) in 1996 to that in 1998?
Your response must be concise. 1. What is the ratio of the Area (in %) of Singapore in 1996 to that in 1998?
Your answer should be very brief. 1. What is the ratio of the Area (in %) of Czech Republic in 1996 to that in 1999?
Ensure brevity in your answer.  1. What is the ratio of the Area (in %) of French Polynesia in 1996 to that in 1999?
Your response must be concise. 1. What is the ratio of the Area (in %) of French Polynesia in 1996 to that in 2000?
Offer a terse response. 1. What is the ratio of the Area (in %) of Czech Republic in 1996 to that in 2001?
Offer a very short reply. 1.01. What is the ratio of the Area (in %) in Singapore in 1996 to that in 2001?
Give a very brief answer. 1. What is the ratio of the Area (in %) in Czech Republic in 1997 to that in 1998?
Your answer should be compact. 1. What is the ratio of the Area (in %) in French Polynesia in 1997 to that in 1998?
Give a very brief answer. 1. What is the ratio of the Area (in %) in Korea (Democratic) in 1997 to that in 1998?
Give a very brief answer. 1. What is the ratio of the Area (in %) in Czech Republic in 1997 to that in 1999?
Your response must be concise. 1. What is the ratio of the Area (in %) in Korea (Democratic) in 1997 to that in 1999?
Keep it short and to the point. 1. What is the ratio of the Area (in %) of Singapore in 1997 to that in 1999?
Your answer should be compact. 1. What is the ratio of the Area (in %) of Czech Republic in 1997 to that in 2000?
Your answer should be compact. 1. What is the ratio of the Area (in %) in Czech Republic in 1997 to that in 2001?
Your answer should be compact. 1. What is the ratio of the Area (in %) of French Polynesia in 1997 to that in 2001?
Ensure brevity in your answer.  1. What is the ratio of the Area (in %) of Singapore in 1997 to that in 2001?
Give a very brief answer. 1. What is the ratio of the Area (in %) in Czech Republic in 1998 to that in 1999?
Your response must be concise. 1. What is the ratio of the Area (in %) in French Polynesia in 1998 to that in 1999?
Keep it short and to the point. 1. What is the ratio of the Area (in %) of Korea (Democratic) in 1998 to that in 1999?
Offer a very short reply. 1. What is the ratio of the Area (in %) in Czech Republic in 1998 to that in 2000?
Give a very brief answer. 1.01. What is the ratio of the Area (in %) of French Polynesia in 1998 to that in 2000?
Your answer should be very brief. 1. What is the ratio of the Area (in %) of Czech Republic in 1998 to that in 2001?
Ensure brevity in your answer.  1.01. What is the ratio of the Area (in %) of French Polynesia in 1998 to that in 2001?
Your response must be concise. 1. What is the ratio of the Area (in %) in French Polynesia in 1999 to that in 2000?
Provide a succinct answer. 1. What is the ratio of the Area (in %) of Korea (Democratic) in 1999 to that in 2000?
Make the answer very short. 1. What is the ratio of the Area (in %) in Singapore in 1999 to that in 2000?
Make the answer very short. 1. What is the ratio of the Area (in %) in Singapore in 1999 to that in 2001?
Provide a succinct answer. 1. What is the ratio of the Area (in %) in Czech Republic in 2000 to that in 2001?
Provide a short and direct response. 1. What is the ratio of the Area (in %) of French Polynesia in 2000 to that in 2001?
Keep it short and to the point. 1. What is the difference between the highest and the second highest Area (in %) in Czech Republic?
Your answer should be very brief. 0.21. What is the difference between the highest and the second highest Area (in %) of Korea (Democratic)?
Make the answer very short. 0. What is the difference between the highest and the lowest Area (in %) in Czech Republic?
Offer a terse response. 1.05. What is the difference between the highest and the lowest Area (in %) of French Polynesia?
Offer a very short reply. 0. What is the difference between the highest and the lowest Area (in %) of Korea (Democratic)?
Ensure brevity in your answer.  0.83. What is the difference between the highest and the lowest Area (in %) in Singapore?
Provide a short and direct response. 0. 